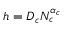Convert formula to latex. <formula><loc_0><loc_0><loc_500><loc_500>h = D _ { c } N _ { c } ^ { \alpha _ { c } }</formula> 